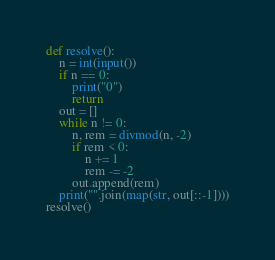<code> <loc_0><loc_0><loc_500><loc_500><_Python_>def resolve():
	n = int(input())
	if n == 0:
		print("0")
		return
	out = []
	while n != 0:
		n, rem = divmod(n, -2)
		if rem < 0:
			n += 1
			rem -= -2
		out.append(rem)
	print("".join(map(str, out[::-1])))
resolve()</code> 